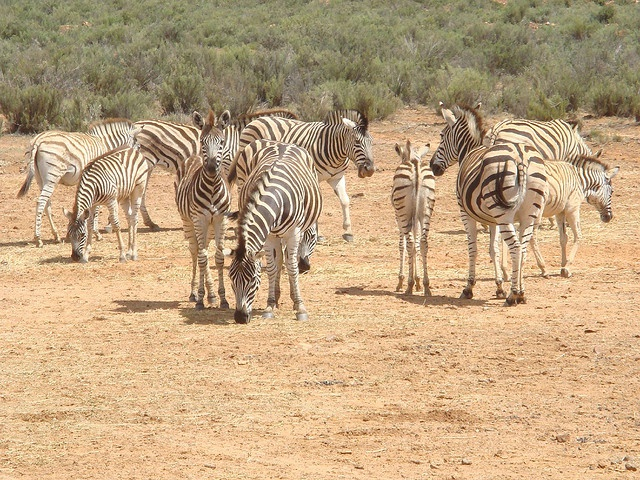Describe the objects in this image and their specific colors. I can see zebra in gray, tan, and maroon tones, zebra in gray, beige, tan, and darkgray tones, zebra in gray, tan, and maroon tones, zebra in gray, tan, and beige tones, and zebra in gray, beige, and tan tones in this image. 